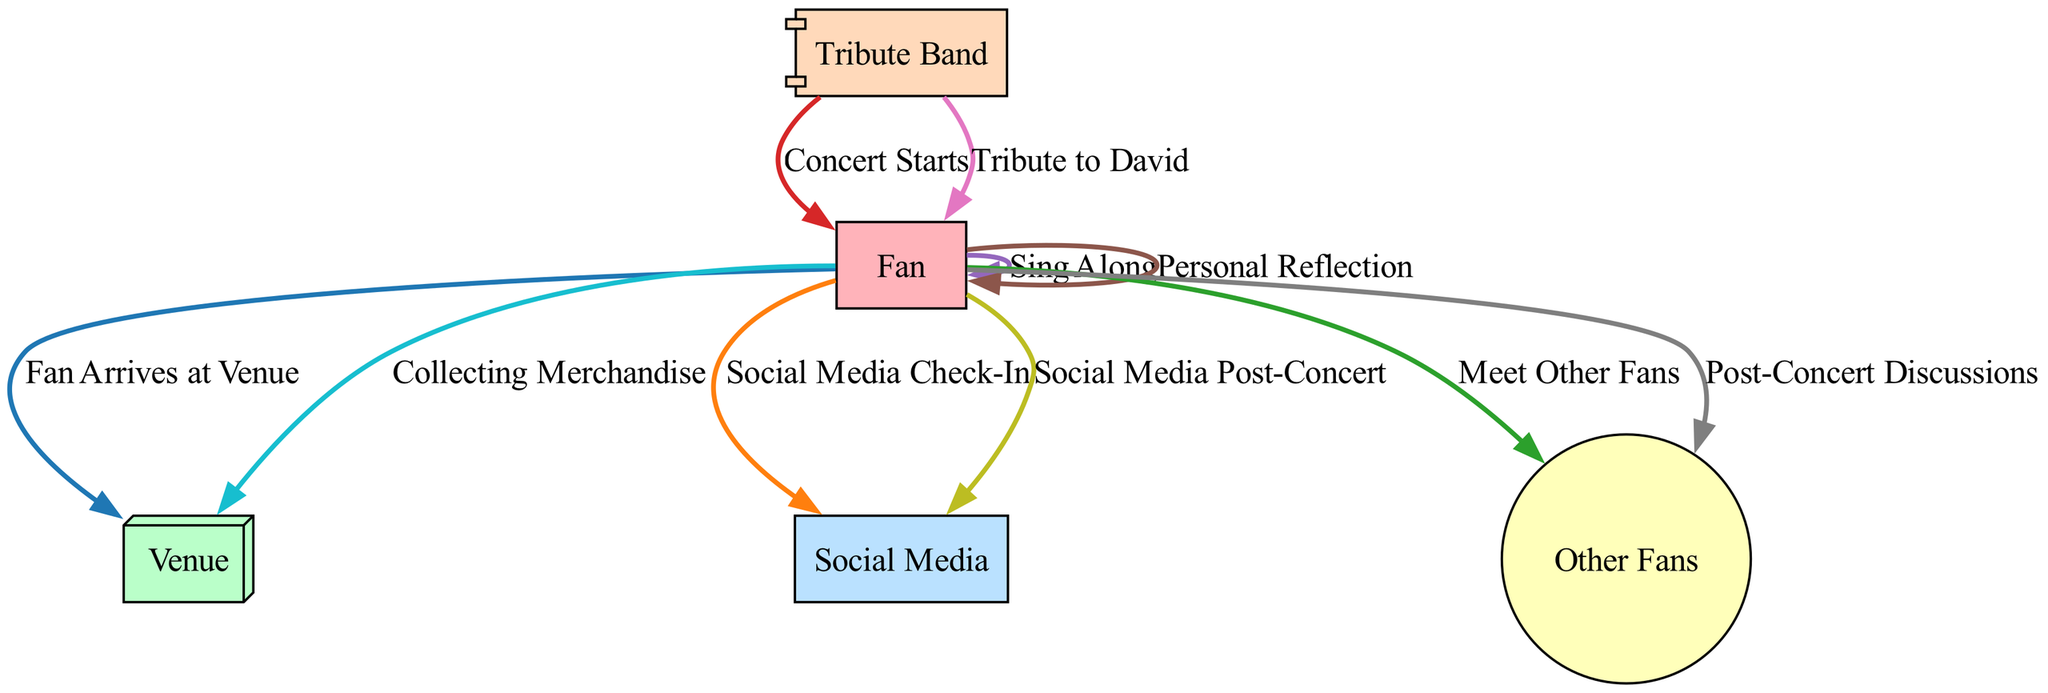What is the first event recorded in the diagram? The first event in the sequence is "Fan Arrives at Venue". This event is positioned at the top of the diagram and indicates the initial action taken by the fan upon arriving at the concert venue.
Answer: Fan Arrives at Venue How many main nodes are present in the diagram? The diagram consists of five main nodes: Fan, Venue, Social Media, Other Fans, and Tribute Band. Each node represents a different aspect of the fan's experience during the concert.
Answer: 5 What action does the fan take after arriving at the venue? After arriving at the venue, the fan performs the action of checking in on social media, which is represented by an edge from the Fan node to the Social Media node.
Answer: Social Media Check-In Which event directly follows the concert starting? Following the event labeled "Concert Starts" is the "Sing Along" event. This event captures the fan's participation by singing along to the music performed by the tribute band.
Answer: Sing Along How many connections lead to the Other Fans node? The Other Fans node has two connections: one from "Meet Other Fans" and another from "Post-Concert Discussions". This indicates that the fan interacts with other fans both during and after the concert.
Answer: 2 What event initiates the fan's personal reflection? The fan's personal reflection is initiated during the event "Personal Reflection", which occurs in conjunction with a slower song performed during the concert. This indicates a moment of introspection prompted by the music.
Answer: Personal Reflection Which event involves the tribute band sharing stories? The event during which the tribute band shares stories about David McComb is labeled "Tribute to David". This event receives emotional responses and applause from the audience, highlighting the tribute band's role in honoring McComb's legacy.
Answer: Tribute to David What merchandise does the fan collect? The fan collects merchandise after the concert, which includes a concert poster and a vinyl record of The Triffids. This action signifies a tangible way for the fan to remember the event.
Answer: Collecting Merchandise 